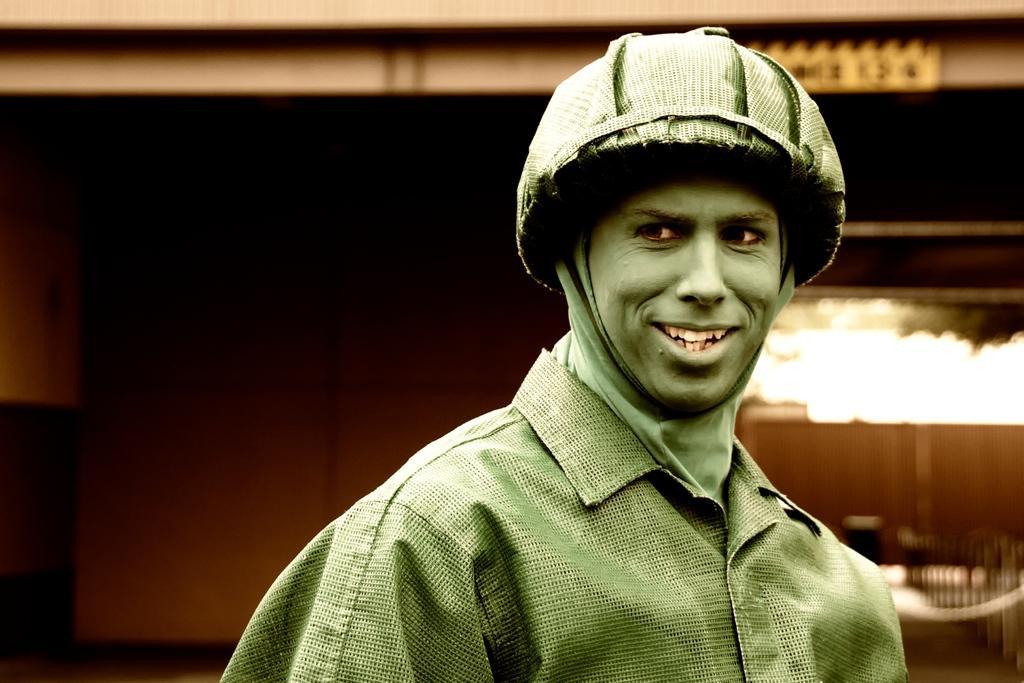Could you give a brief overview of what you see in this image? In this picture we can see a man. There is a building in the background. 